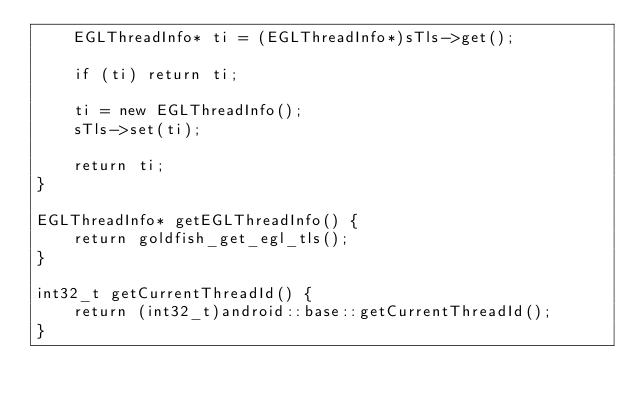<code> <loc_0><loc_0><loc_500><loc_500><_C++_>    EGLThreadInfo* ti = (EGLThreadInfo*)sTls->get();

    if (ti) return ti;

    ti = new EGLThreadInfo();
    sTls->set(ti);

    return ti;
}

EGLThreadInfo* getEGLThreadInfo() {
    return goldfish_get_egl_tls();
}

int32_t getCurrentThreadId() {
    return (int32_t)android::base::getCurrentThreadId();
}
</code> 